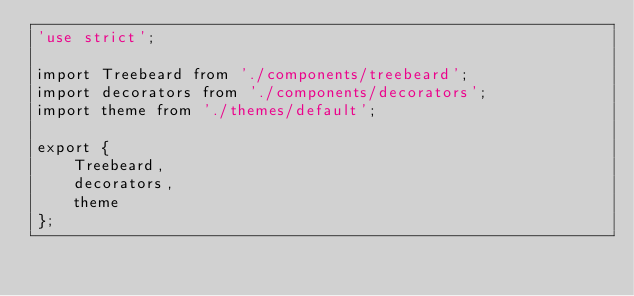<code> <loc_0><loc_0><loc_500><loc_500><_JavaScript_>'use strict';

import Treebeard from './components/treebeard';
import decorators from './components/decorators';
import theme from './themes/default';

export {
    Treebeard,
    decorators,
    theme
};
</code> 